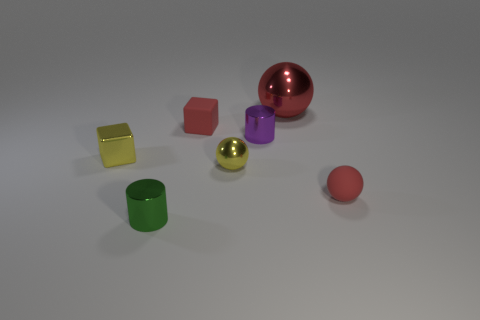Subtract all red balls. How many balls are left? 1 Subtract all balls. How many objects are left? 4 Add 1 tiny green metallic objects. How many objects exist? 8 Subtract all brown cylinders. Subtract all yellow blocks. How many cylinders are left? 2 Subtract all yellow cylinders. How many red cubes are left? 1 Subtract all tiny red things. Subtract all tiny yellow shiny spheres. How many objects are left? 4 Add 5 tiny metal spheres. How many tiny metal spheres are left? 6 Add 3 shiny things. How many shiny things exist? 8 Subtract all red blocks. How many blocks are left? 1 Subtract 0 yellow cylinders. How many objects are left? 7 